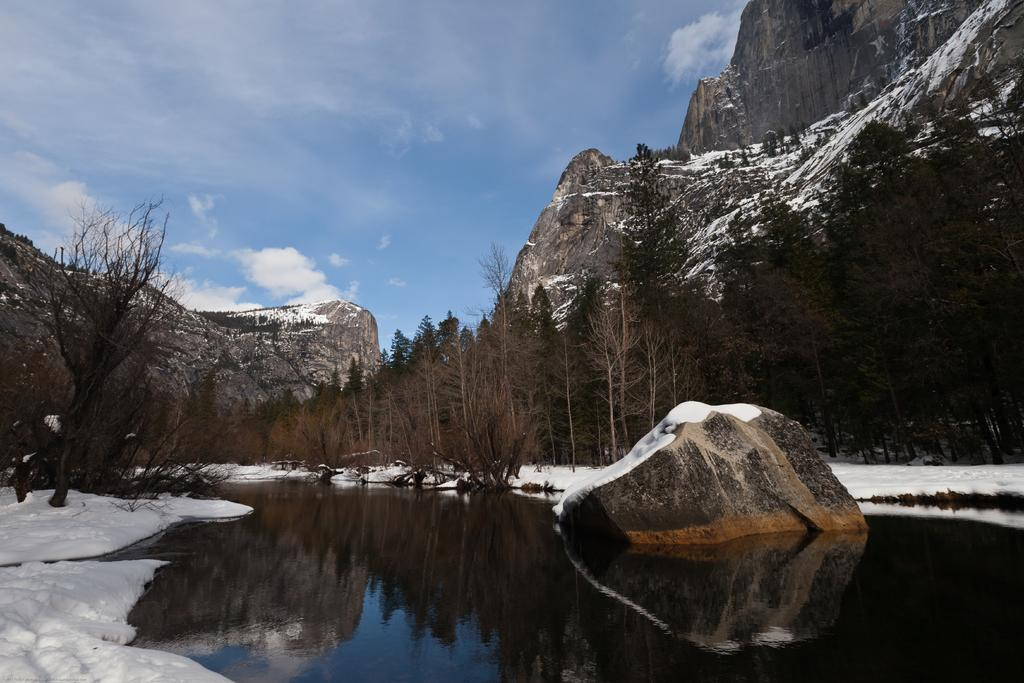What type of natural landscape is depicted in the image? The image features mountains, trees, and snow, indicating a winter landscape. Can you describe any specific features of the mountains? The mountains are covered in snow, suggesting a high altitude and cold climate. What other objects or elements can be seen in the image? There is a big stone and water visible in the image. How would you describe the sky in the image? The sky is cloudy in the image. How much money is being exchanged between the sisters in the image? There are no people, money, or sisters present in the image; it features a winter landscape with mountains, trees, snow, a big stone, and water. 